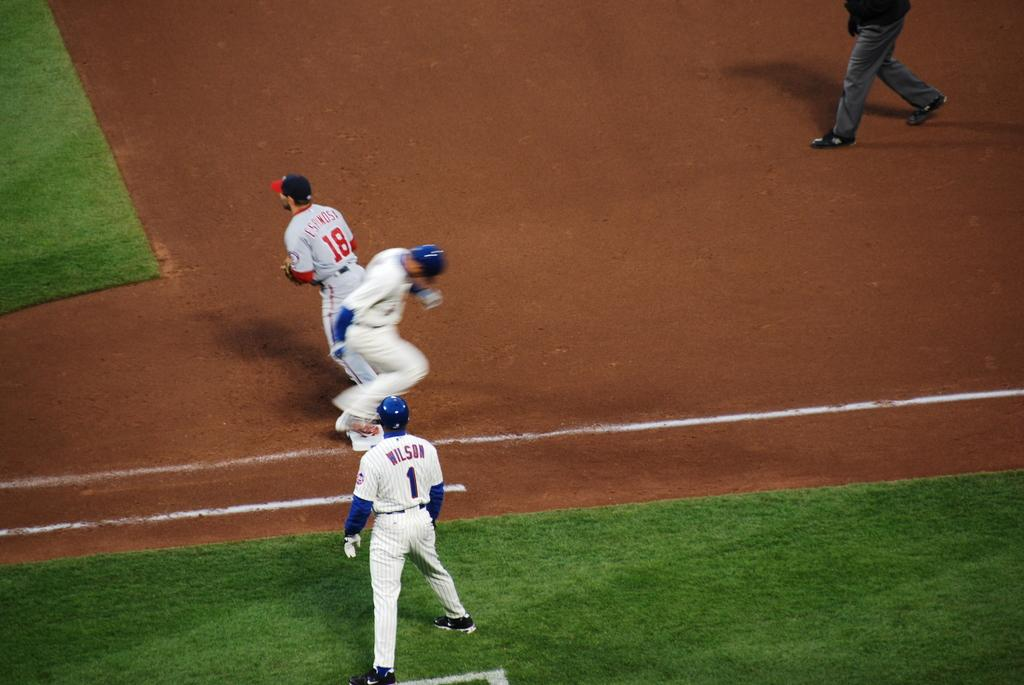<image>
Present a compact description of the photo's key features. A baseball player runs onto first base while the first baseman waits for the ball. 